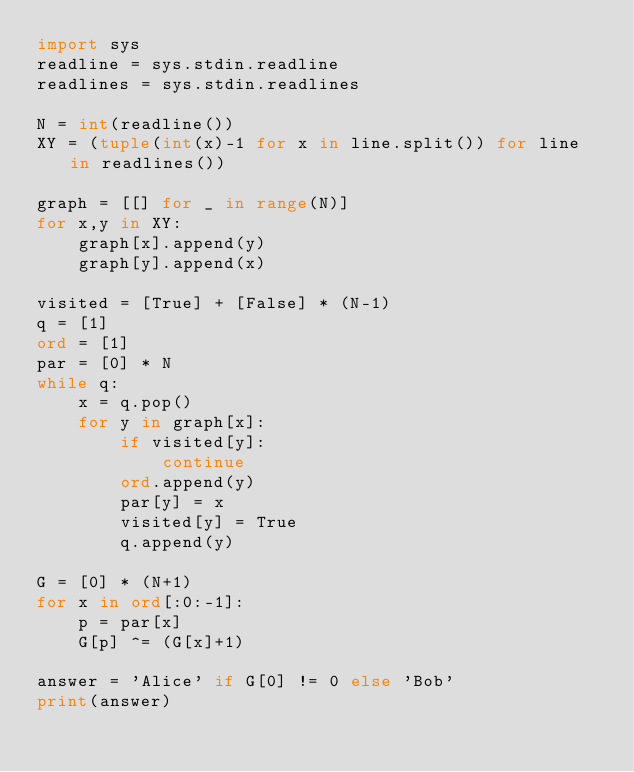<code> <loc_0><loc_0><loc_500><loc_500><_Python_>import sys
readline = sys.stdin.readline
readlines = sys.stdin.readlines

N = int(readline())
XY = (tuple(int(x)-1 for x in line.split()) for line in readlines())

graph = [[] for _ in range(N)]
for x,y in XY:
    graph[x].append(y)
    graph[y].append(x)

visited = [True] + [False] * (N-1)
q = [1]
ord = [1]
par = [0] * N
while q:
    x = q.pop()
    for y in graph[x]:
        if visited[y]:
            continue
        ord.append(y)
        par[y] = x
        visited[y] = True
        q.append(y)

G = [0] * (N+1)
for x in ord[:0:-1]:
    p = par[x]
    G[p] ^= (G[x]+1)

answer = 'Alice' if G[0] != 0 else 'Bob'
print(answer)
</code> 